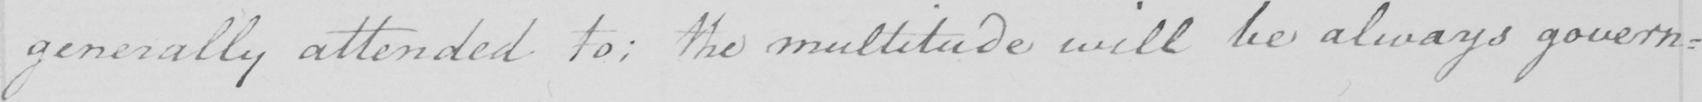Please provide the text content of this handwritten line. generally attended to :  the multitude will be always govern : 